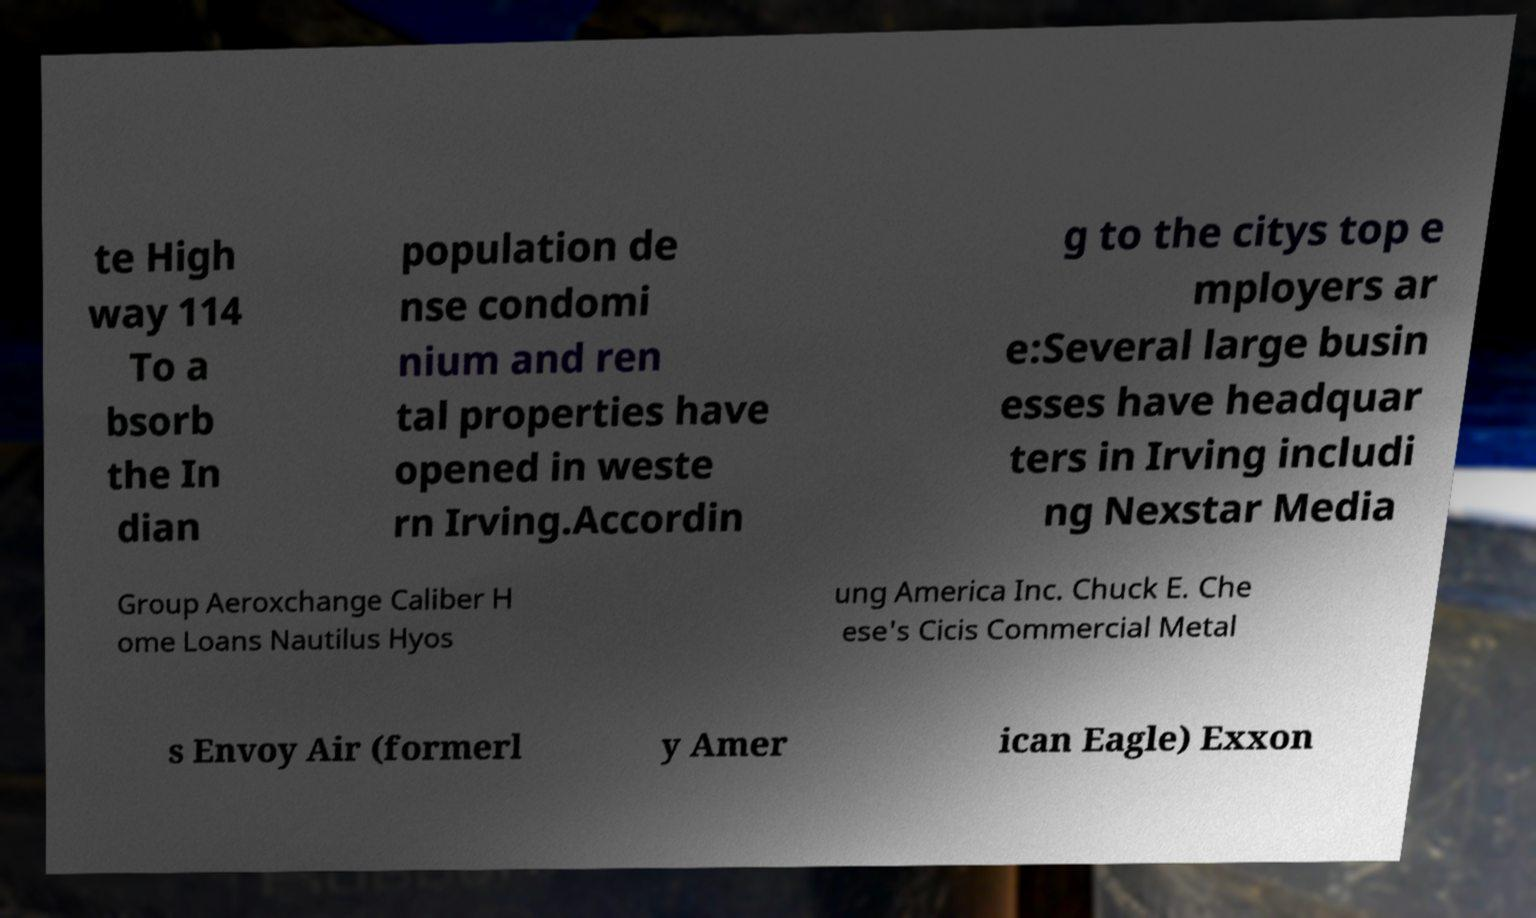Please identify and transcribe the text found in this image. te High way 114 To a bsorb the In dian population de nse condomi nium and ren tal properties have opened in weste rn Irving.Accordin g to the citys top e mployers ar e:Several large busin esses have headquar ters in Irving includi ng Nexstar Media Group Aeroxchange Caliber H ome Loans Nautilus Hyos ung America Inc. Chuck E. Che ese's Cicis Commercial Metal s Envoy Air (formerl y Amer ican Eagle) Exxon 